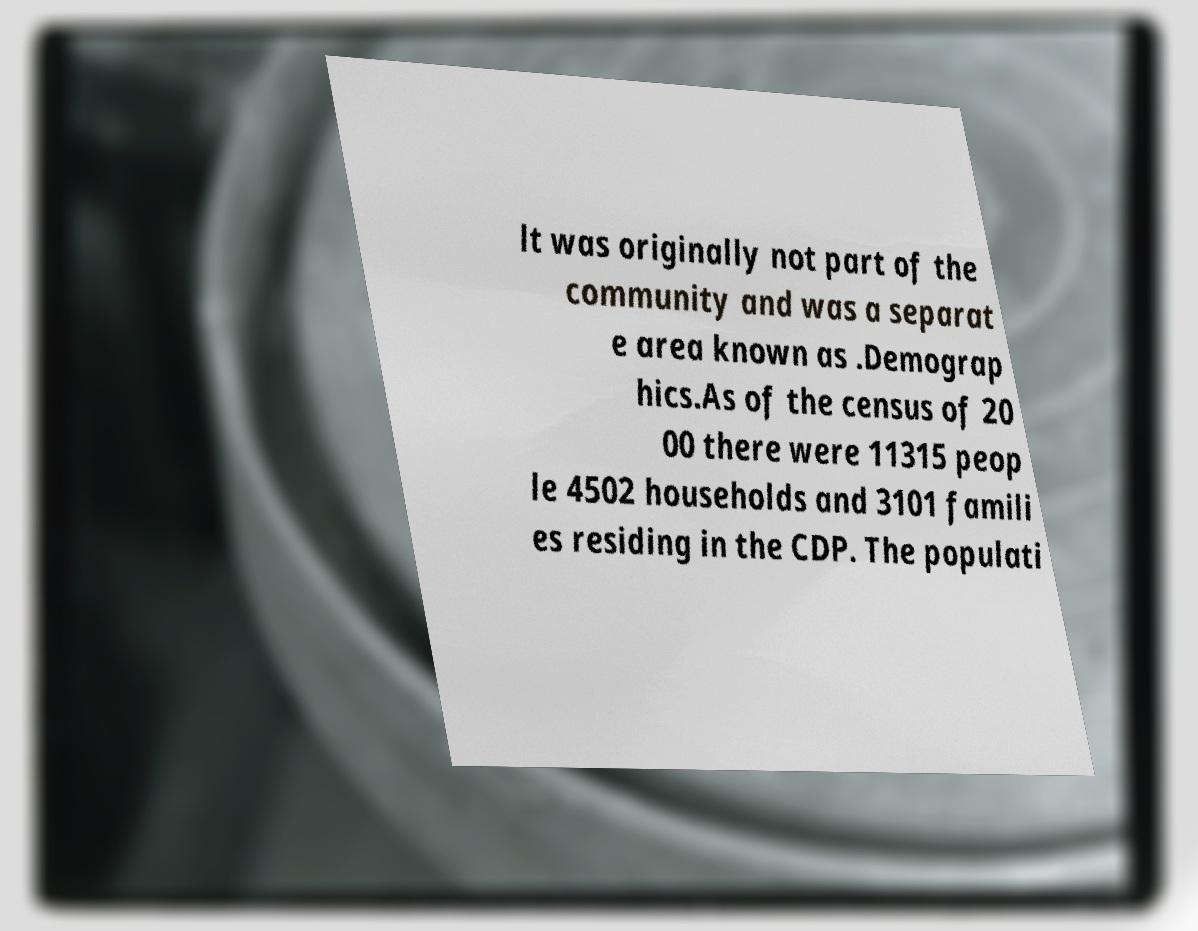Please read and relay the text visible in this image. What does it say? lt was originally not part of the community and was a separat e area known as .Demograp hics.As of the census of 20 00 there were 11315 peop le 4502 households and 3101 famili es residing in the CDP. The populati 